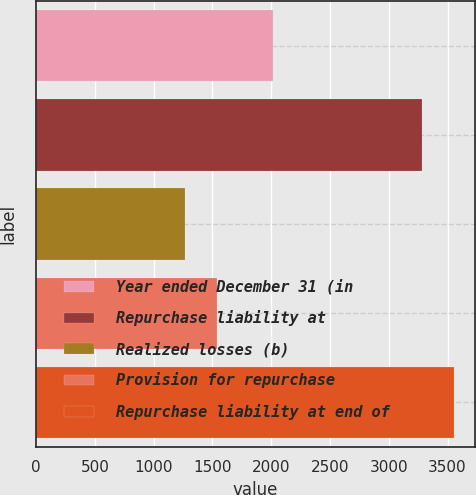<chart> <loc_0><loc_0><loc_500><loc_500><bar_chart><fcel>Year ended December 31 (in<fcel>Repurchase liability at<fcel>Realized losses (b)<fcel>Provision for repurchase<fcel>Repurchase liability at end of<nl><fcel>2011<fcel>3285<fcel>1263<fcel>1535<fcel>3557<nl></chart> 